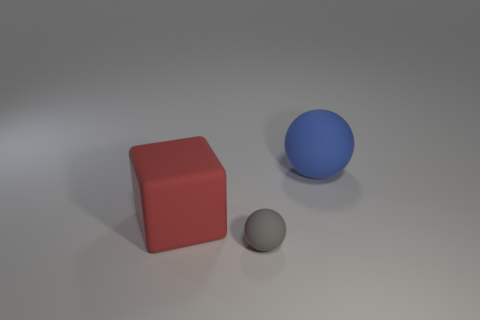What number of other things are there of the same size as the gray sphere?
Your response must be concise. 0. What number of other objects are there of the same shape as the small thing?
Your answer should be very brief. 1. Are there any big brown objects that have the same material as the tiny gray thing?
Provide a succinct answer. No. What material is the red block that is the same size as the blue rubber object?
Provide a short and direct response. Rubber. There is a ball on the left side of the big matte thing behind the big rubber thing that is on the left side of the blue rubber sphere; what color is it?
Your answer should be compact. Gray. There is a big rubber thing behind the big red matte thing; is its shape the same as the big object to the left of the small gray thing?
Provide a succinct answer. No. What number of tiny green matte cylinders are there?
Provide a short and direct response. 0. The ball that is the same size as the red object is what color?
Your answer should be compact. Blue. Is the material of the sphere left of the large blue rubber thing the same as the big thing that is left of the blue matte sphere?
Offer a terse response. Yes. How big is the rubber object behind the big block left of the big ball?
Your answer should be very brief. Large. 